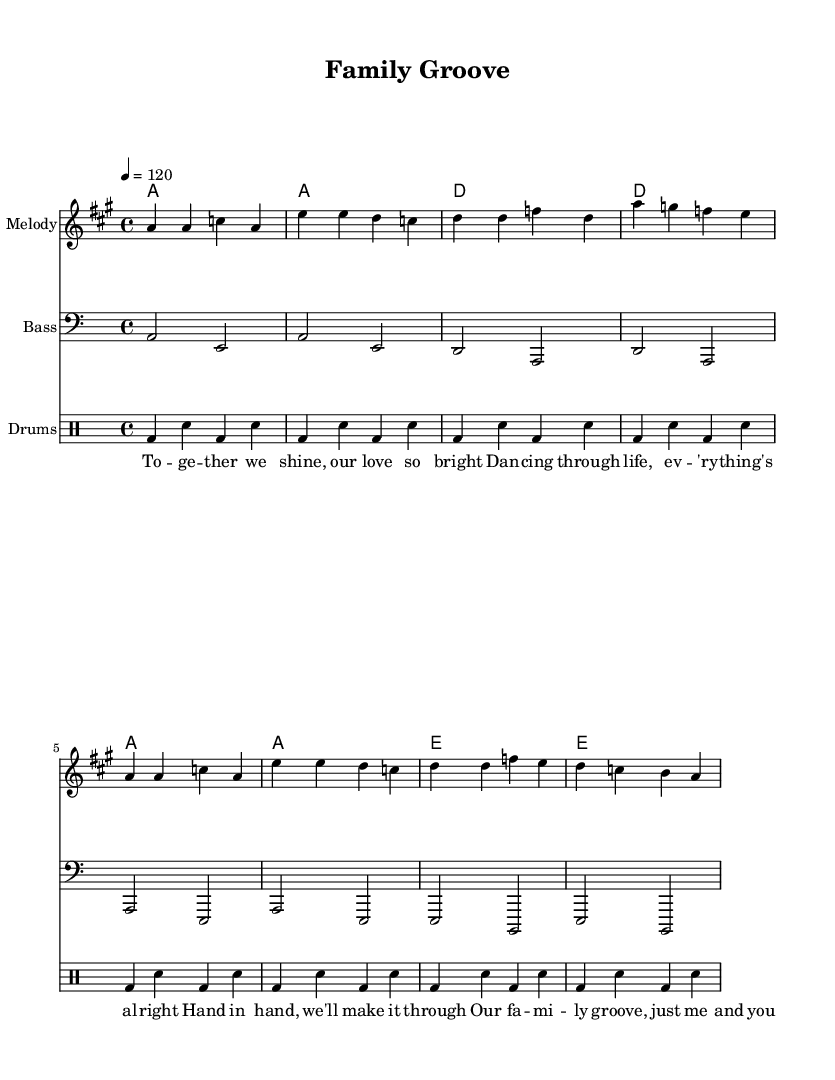What is the time signature of this music? The time signature is indicated at the beginning of the score, represented as 4/4, which means there are four beats in each measure.
Answer: 4/4 What is the tempo marking for this piece? The tempo marking is found at the beginning of the score where it indicates the tempo as 4 = 120, meaning there are 120 beats per minute.
Answer: 120 How many measures are in the melody section? The melody section consists of eight measures, which can be counted visually since each vertical line on the staff represents a measure.
Answer: 8 What key is this piece written in? The key signature is indicated at the beginning of the score as one sharp, which corresponds to the key of A major.
Answer: A major What instruments are included in this score? The score contains parts for Melody, Bass, and Drums, each indicated by a separate staff at the beginning of the score.
Answer: Melody, Bass, Drums What is the main theme of the lyrics presented in the music? The lyrics emphasize family unity and support, as seen in phrases like "together we shine" and "our family groove."
Answer: Family unity How many chords are used in the harmonies section? The harmonies section includes four different chords arranged, which can be counted by identifying each distinct chord symbol used in the measures.
Answer: 4 